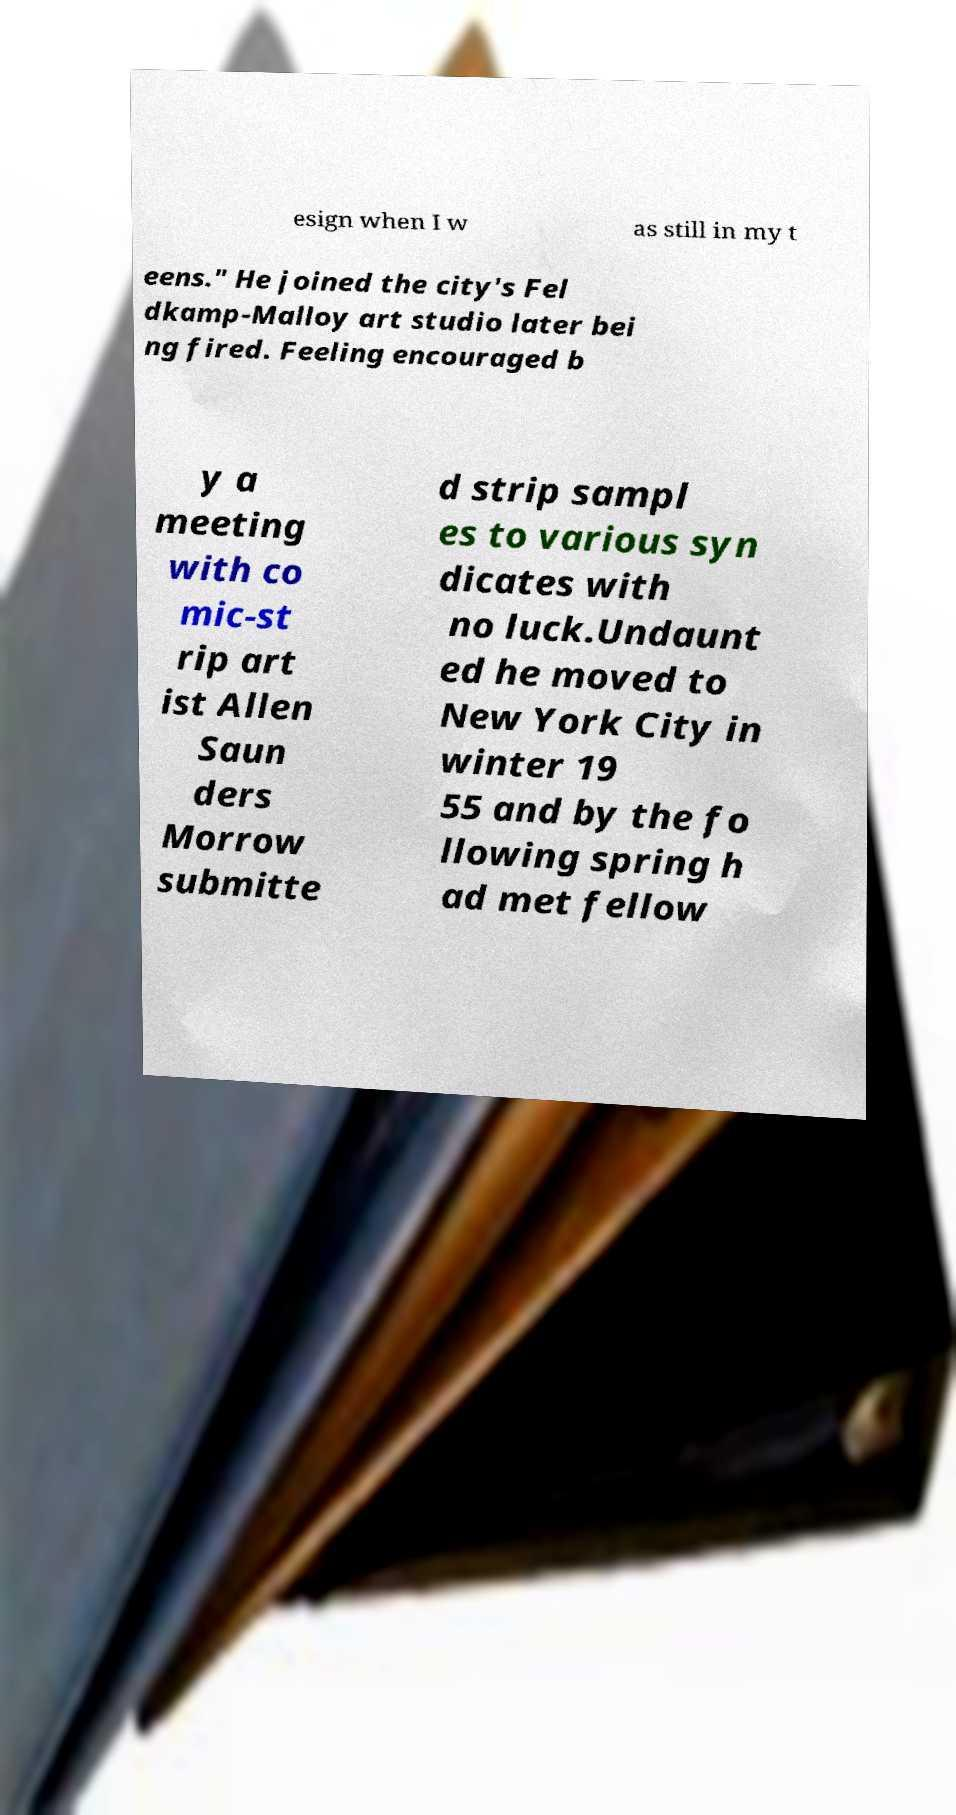Can you read and provide the text displayed in the image?This photo seems to have some interesting text. Can you extract and type it out for me? esign when I w as still in my t eens." He joined the city's Fel dkamp-Malloy art studio later bei ng fired. Feeling encouraged b y a meeting with co mic-st rip art ist Allen Saun ders Morrow submitte d strip sampl es to various syn dicates with no luck.Undaunt ed he moved to New York City in winter 19 55 and by the fo llowing spring h ad met fellow 